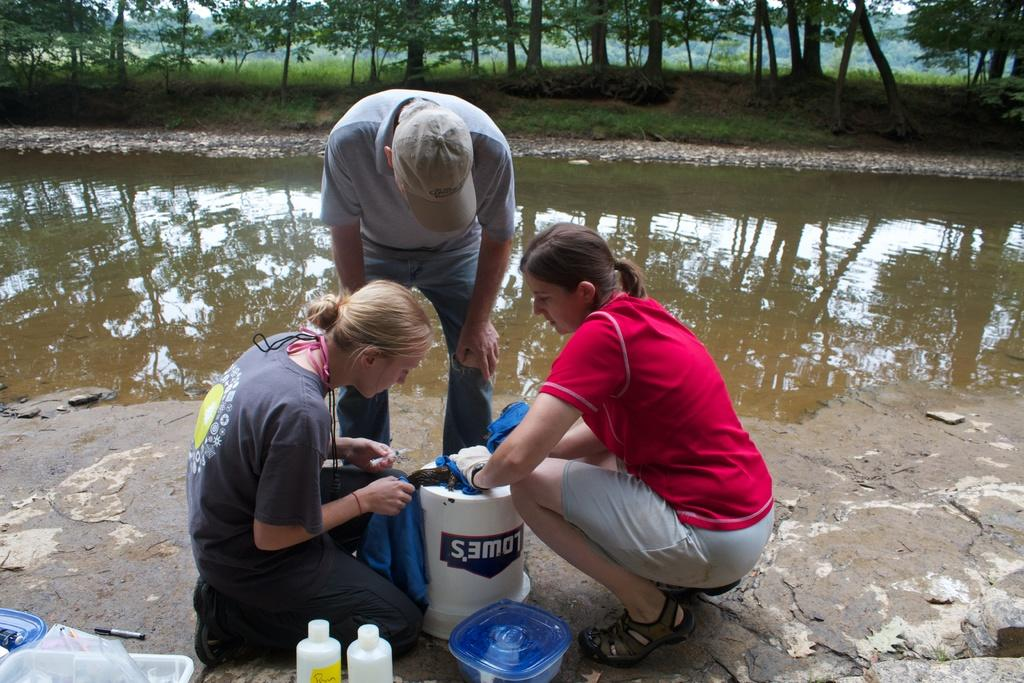What are the two women doing in the image? The two women are in the squat position in the image. What is the man doing in the image? The man is bending in the image. What activity are the people engaged in? The people are trying to knot a tie. What objects can be seen in the image besides the people? There are boxes, bottles, and a pen in the image. What natural elements are present in the image? There is water and trees in the image. What type of cracker is being used to knot the tie in the image? There is no cracker present in the image; the people are using their hands to knot the tie. Can you see any fish swimming in the water in the image? There are no fish visible in the image; only water and trees can be seen. 